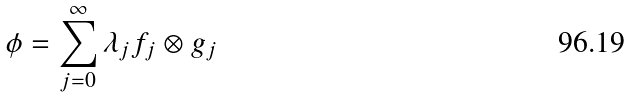Convert formula to latex. <formula><loc_0><loc_0><loc_500><loc_500>\phi = \sum _ { j = 0 } ^ { \infty } \lambda _ { j } f _ { j } \otimes g _ { j }</formula> 